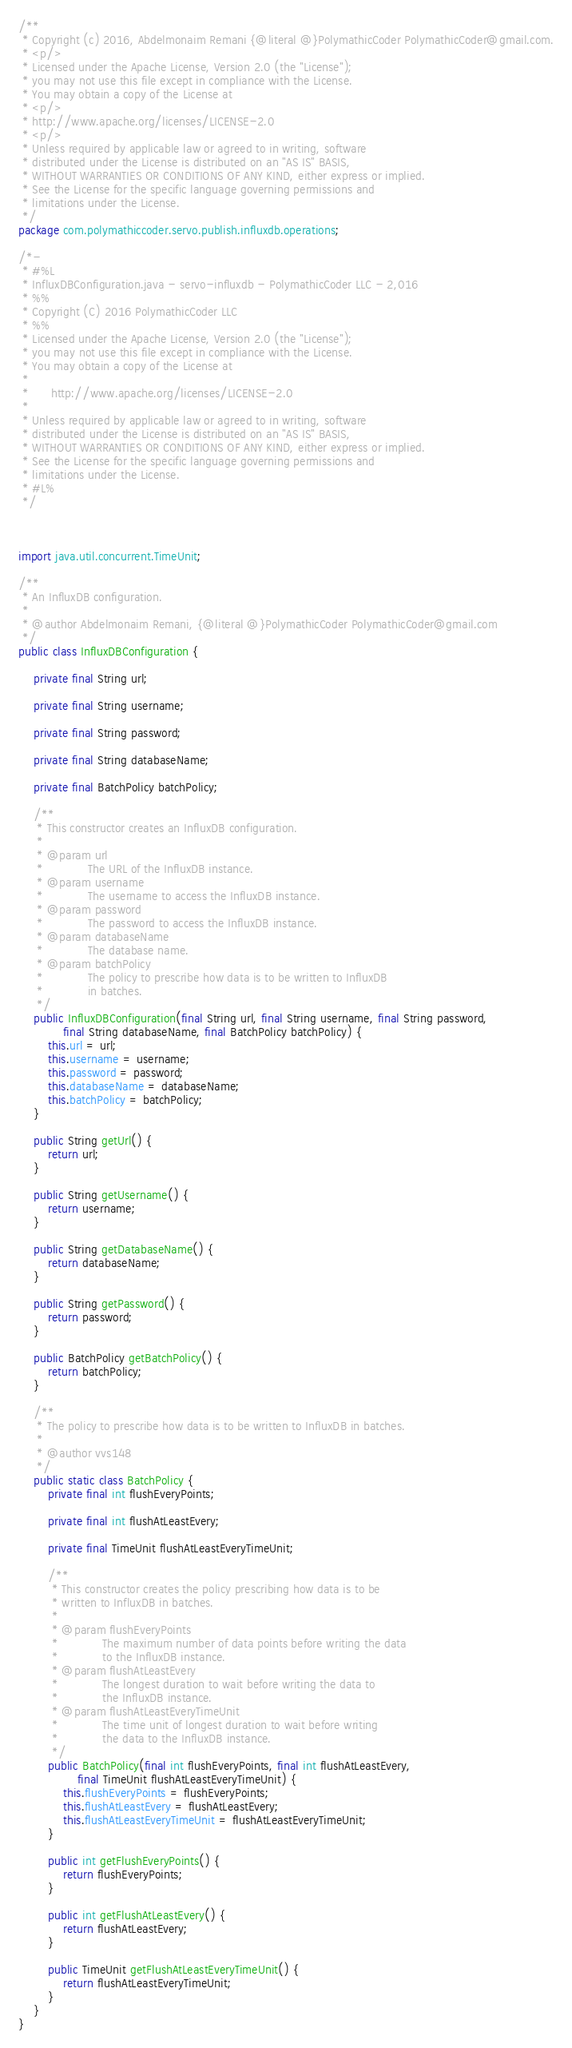Convert code to text. <code><loc_0><loc_0><loc_500><loc_500><_Java_>/**
 * Copyright (c) 2016, Abdelmonaim Remani {@literal @}PolymathicCoder PolymathicCoder@gmail.com.
 * <p/>
 * Licensed under the Apache License, Version 2.0 (the "License");
 * you may not use this file except in compliance with the License.
 * You may obtain a copy of the License at
 * <p/>
 * http://www.apache.org/licenses/LICENSE-2.0
 * <p/>
 * Unless required by applicable law or agreed to in writing, software
 * distributed under the License is distributed on an "AS IS" BASIS,
 * WITHOUT WARRANTIES OR CONDITIONS OF ANY KIND, either express or implied.
 * See the License for the specific language governing permissions and
 * limitations under the License.
 */
package com.polymathiccoder.servo.publish.influxdb.operations;

/*-
 * #%L
 * InfluxDBConfiguration.java - servo-influxdb - PolymathicCoder LLC - 2,016
 * %%
 * Copyright (C) 2016 PolymathicCoder LLC
 * %%
 * Licensed under the Apache License, Version 2.0 (the "License");
 * you may not use this file except in compliance with the License.
 * You may obtain a copy of the License at
 * 
 *      http://www.apache.org/licenses/LICENSE-2.0
 * 
 * Unless required by applicable law or agreed to in writing, software
 * distributed under the License is distributed on an "AS IS" BASIS,
 * WITHOUT WARRANTIES OR CONDITIONS OF ANY KIND, either express or implied.
 * See the License for the specific language governing permissions and
 * limitations under the License.
 * #L%
 */



import java.util.concurrent.TimeUnit;

/**
 * An InfluxDB configuration.
 *
 * @author Abdelmonaim Remani, {@literal @}PolymathicCoder PolymathicCoder@gmail.com
 */
public class InfluxDBConfiguration {

    private final String url;

    private final String username;

    private final String password;

    private final String databaseName;

    private final BatchPolicy batchPolicy;

    /**
     * This constructor creates an InfluxDB configuration.
     *
     * @param url
     *            The URL of the InfluxDB instance.
     * @param username
     *            The username to access the InfluxDB instance.
     * @param password
     *            The password to access the InfluxDB instance.
     * @param databaseName
     *            The database name.
     * @param batchPolicy
     *            The policy to prescribe how data is to be written to InfluxDB
     *            in batches.
     */
    public InfluxDBConfiguration(final String url, final String username, final String password,
            final String databaseName, final BatchPolicy batchPolicy) {
        this.url = url;
        this.username = username;
        this.password = password;
        this.databaseName = databaseName;
        this.batchPolicy = batchPolicy;
    }

    public String getUrl() {
        return url;
    }

    public String getUsername() {
        return username;
    }

    public String getDatabaseName() {
        return databaseName;
    }

    public String getPassword() {
        return password;
    }

    public BatchPolicy getBatchPolicy() {
        return batchPolicy;
    }

    /**
     * The policy to prescribe how data is to be written to InfluxDB in batches.
     *
     * @author vvs148
     */
    public static class BatchPolicy {
        private final int flushEveryPoints;

        private final int flushAtLeastEvery;

        private final TimeUnit flushAtLeastEveryTimeUnit;

        /**
         * This constructor creates the policy prescribing how data is to be
         * written to InfluxDB in batches.
         *
         * @param flushEveryPoints
         *            The maximum number of data points before writing the data
         *            to the InfluxDB instance.
         * @param flushAtLeastEvery
         *            The longest duration to wait before writing the data to
         *            the InfluxDB instance.
         * @param flushAtLeastEveryTimeUnit
         *            The time unit of longest duration to wait before writing
         *            the data to the InfluxDB instance.
         */
        public BatchPolicy(final int flushEveryPoints, final int flushAtLeastEvery,
                final TimeUnit flushAtLeastEveryTimeUnit) {
            this.flushEveryPoints = flushEveryPoints;
            this.flushAtLeastEvery = flushAtLeastEvery;
            this.flushAtLeastEveryTimeUnit = flushAtLeastEveryTimeUnit;
        }

        public int getFlushEveryPoints() {
            return flushEveryPoints;
        }

        public int getFlushAtLeastEvery() {
            return flushAtLeastEvery;
        }

        public TimeUnit getFlushAtLeastEveryTimeUnit() {
            return flushAtLeastEveryTimeUnit;
        }
    }
}
</code> 